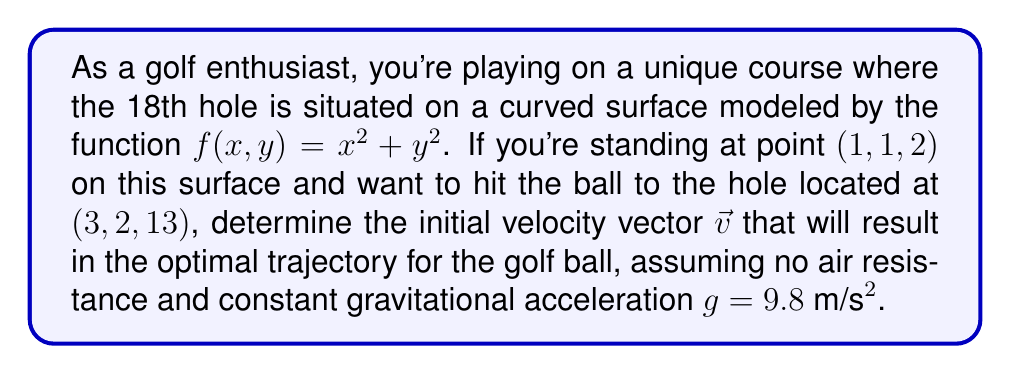Provide a solution to this math problem. To solve this problem, we'll use the principles of differential geometry and the calculus of variations on manifolds. Let's break it down step-by-step:

1) First, we need to understand the surface. The function $f(x,y) = x^2 + y^2$ describes a paraboloid. The gradient of this surface at any point $(x,y)$ is:

   $$\nabla f = (2x, 2y, -1)$$

2) The tangent plane at the initial point $(1,1,2)$ is perpendicular to the normal vector $\vec{n} = (2,2,-1)$ at that point.

3) The optimal trajectory will be a geodesic on this surface. In the absence of air resistance, this path minimizes the action integral:

   $$S = \int_{t_1}^{t_2} L dt$$

   where $L = T - V$ is the Lagrangian, $T$ is the kinetic energy, and $V$ is the potential energy.

4) The Euler-Lagrange equations for this system are:

   $$\frac{d}{dt}\left(\frac{\partial L}{\partial \dot{q}_i}\right) - \frac{\partial L}{\partial q_i} = 0$$

   where $q_i$ are the generalized coordinates.

5) Solving these equations analytically is complex, but we can approximate the initial velocity vector $\vec{v}$ using the following method:

   a) Calculate the displacement vector: $\vec{d} = (2,1,11)$
   b) Project this vector onto the tangent plane at the initial point:
      $$\vec{v} = \vec{d} - (\vec{d} \cdot \hat{n})\hat{n}$$
      where $\hat{n}$ is the unit normal vector.

6) Calculating:
   $$\hat{n} = \frac{(2,2,-1)}{\sqrt{4+4+1}} = \frac{(2,2,-1)}{\sqrt{9}} = \frac{(2,2,-1)}{3}$$
   $$\vec{d} \cdot \hat{n} = \frac{2(2) + 1(2) + 11(-1)}{3} = -\frac{5}{3}$$
   $$\vec{v} = (2,1,11) - (-\frac{5}{3})(\frac{2}{3},\frac{2}{3},-\frac{1}{3})$$
   $$\vec{v} = (2,1,11) + (\frac{10}{9},\frac{10}{9},-\frac{5}{9})$$
   $$\vec{v} = (\frac{28}{9},\frac{19}{9},\frac{94}{9})$$

7) To get the magnitude of this vector, we can adjust it based on the initial kinetic energy needed to reach the hole, considering the gravitational potential energy difference.
Answer: The optimal initial velocity vector for the golf ball's trajectory is approximately:

$$\vec{v} = k(\frac{28}{9},\frac{19}{9},\frac{94}{9})$$

where $k$ is a scaling factor determined by the initial speed needed to reach the hole, considering the gravitational potential energy difference between the start and end points. 